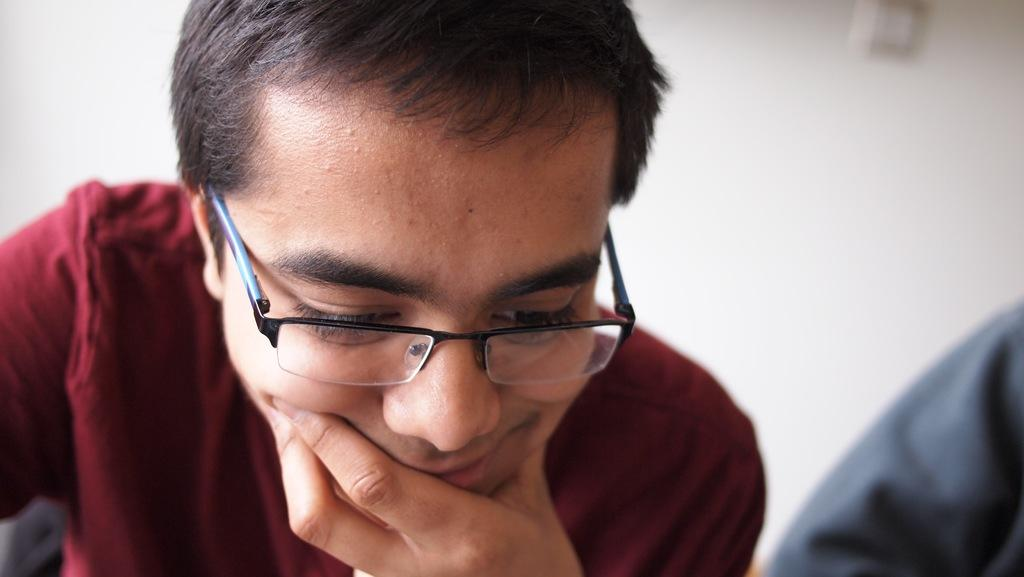What is the main subject in the foreground of the picture? There is a person in the foreground of the picture. What can be observed about the person's appearance? The person is wearing spectacles. What is the person's posture in the image? The person appears to be standing. What can be seen in the background of the picture? There is a wall visible in the background of the picture, along with other objects. What type of fruit is being sold at the market in the image? There is no market or fruit present in the image; it features a person standing with a wall in the background. What type of jeans is the person wearing in the image? The image does not provide information about the person's jeans, as it only shows the person wearing spectacles and standing. 